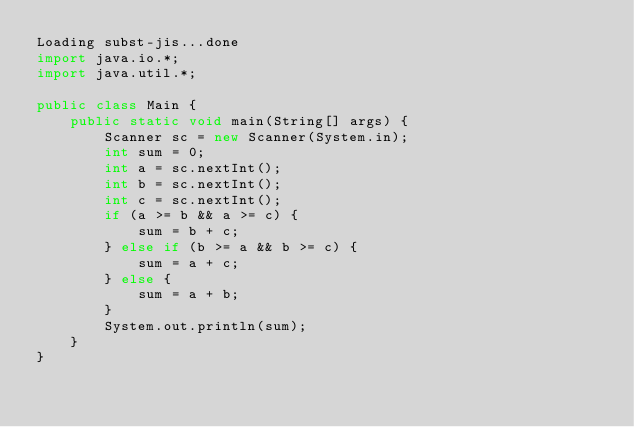Convert code to text. <code><loc_0><loc_0><loc_500><loc_500><_Java_>Loading subst-jis...done
import java.io.*;
import java.util.*;

public class Main {
    public static void main(String[] args) {
        Scanner sc = new Scanner(System.in);
        int sum = 0;
        int a = sc.nextInt();
        int b = sc.nextInt();
        int c = sc.nextInt();
        if (a >= b && a >= c) {
            sum = b + c;
        } else if (b >= a && b >= c) {
            sum = a + c;
        } else {
            sum = a + b;
        }
        System.out.println(sum);
    }
}</code> 